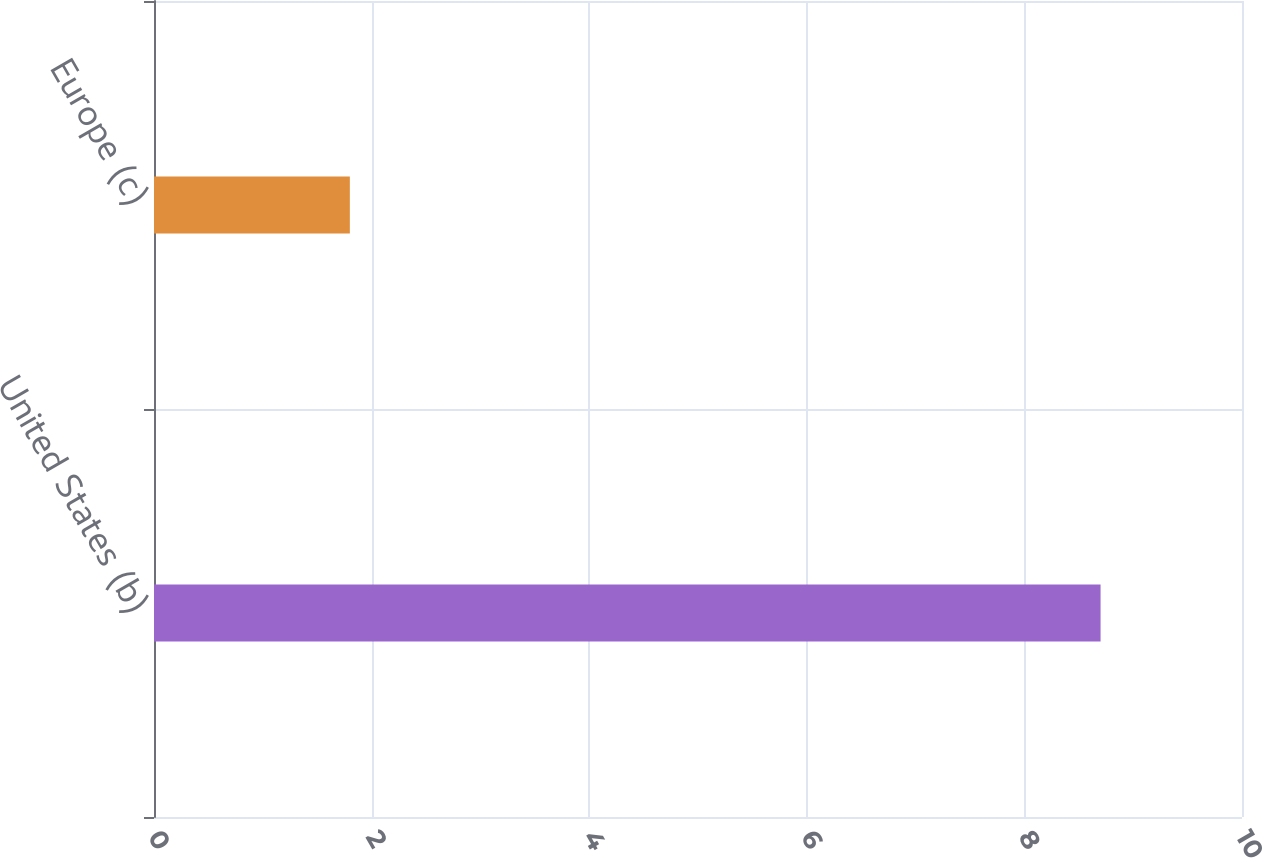Convert chart. <chart><loc_0><loc_0><loc_500><loc_500><bar_chart><fcel>United States (b)<fcel>Europe (c)<nl><fcel>8.7<fcel>1.8<nl></chart> 